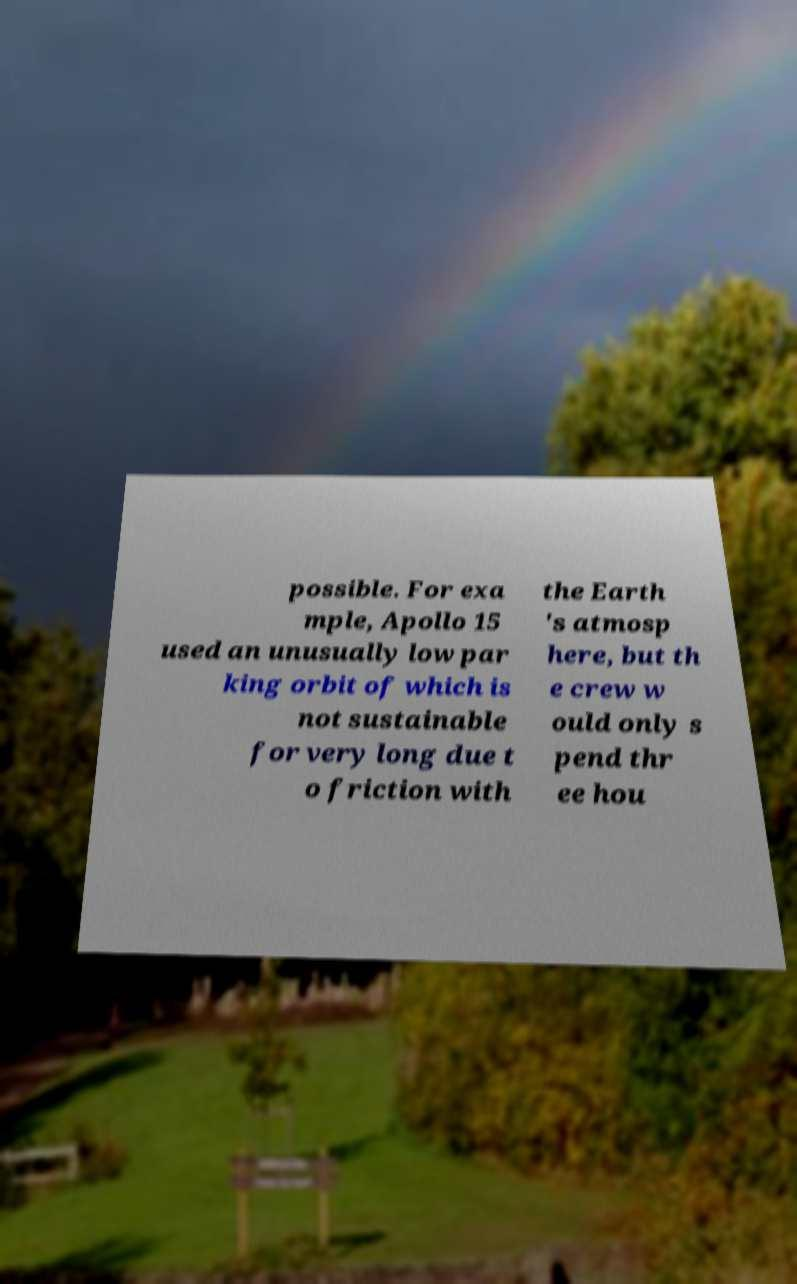For documentation purposes, I need the text within this image transcribed. Could you provide that? possible. For exa mple, Apollo 15 used an unusually low par king orbit of which is not sustainable for very long due t o friction with the Earth 's atmosp here, but th e crew w ould only s pend thr ee hou 